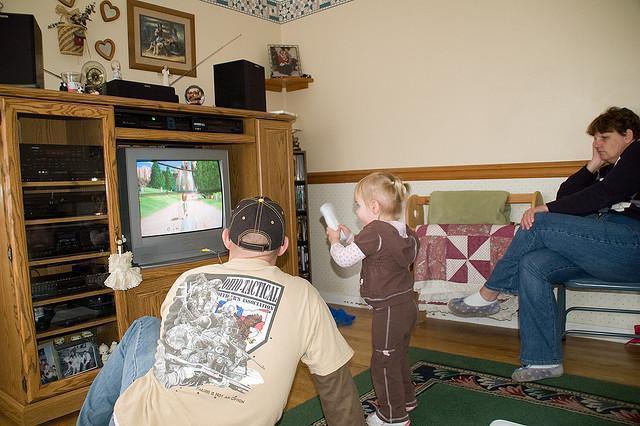What is the young girl doing with the white object?
Indicate the correct response and explain using: 'Answer: answer
Rationale: rationale.'
Options: Singing, playing game, exercising, dancing. Answer: playing game.
Rationale: That is a controller in her hand 